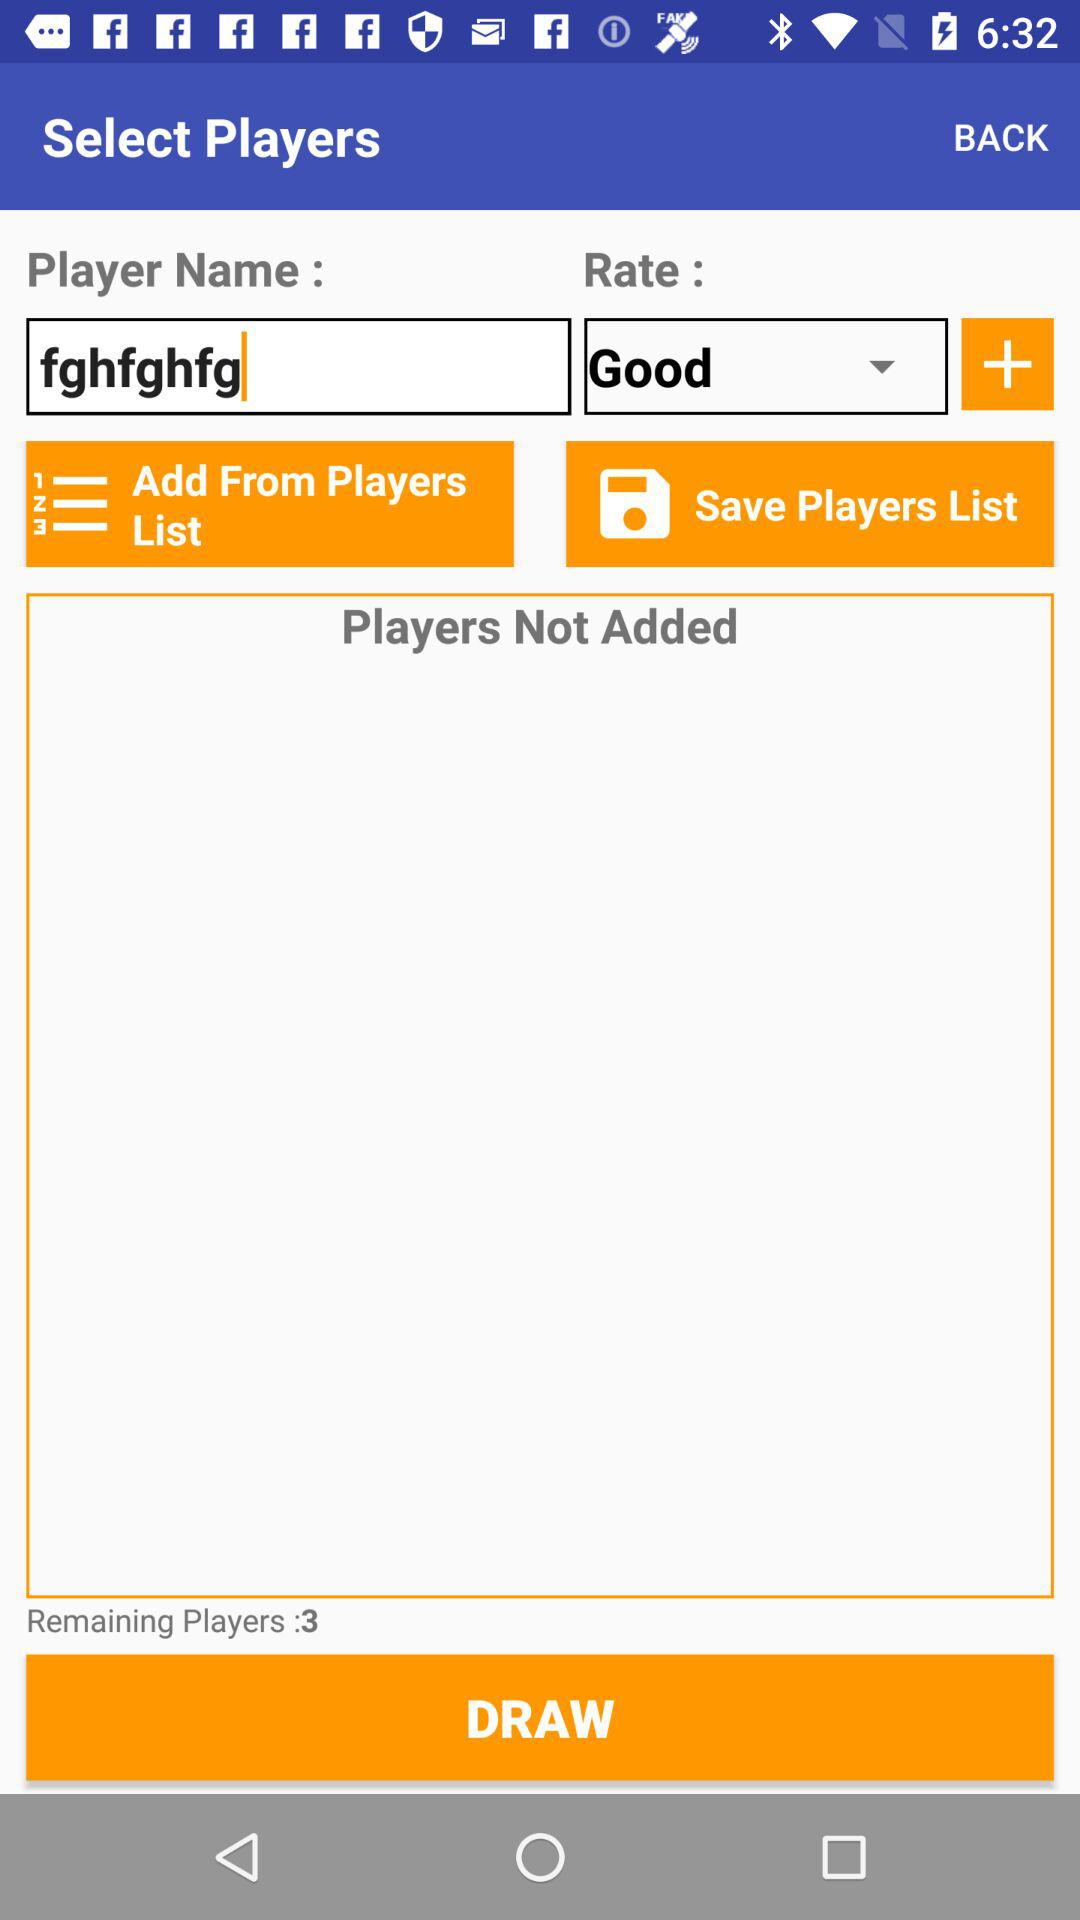How many players have not been added?
Answer the question using a single word or phrase. 3 